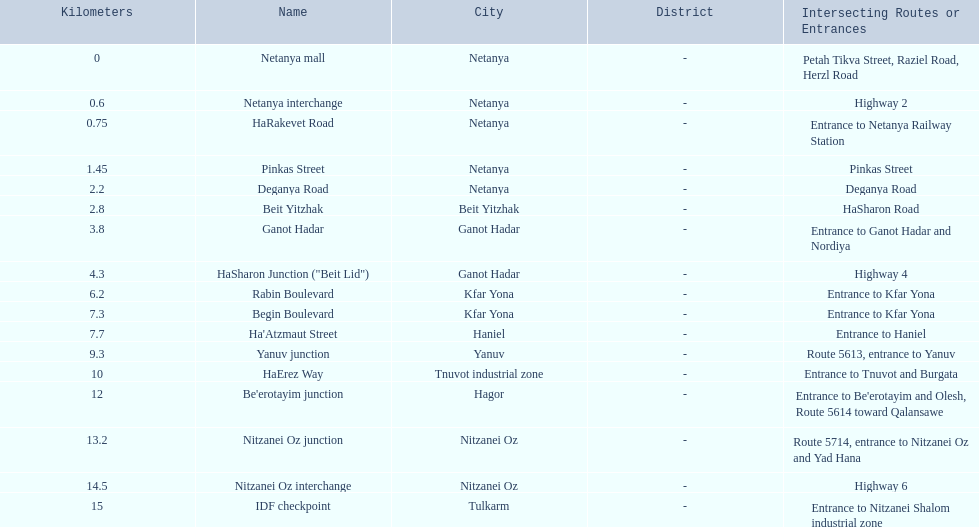What are all of the different portions? Netanya mall, Netanya interchange, HaRakevet Road, Pinkas Street, Deganya Road, Beit Yitzhak, Ganot Hadar, HaSharon Junction ("Beit Lid"), Rabin Boulevard, Begin Boulevard, Ha'Atzmaut Street, Yanuv junction, HaErez Way, Be'erotayim junction, Nitzanei Oz junction, Nitzanei Oz interchange, IDF checkpoint. What is the intersecting route for rabin boulevard? Entrance to Kfar Yona. What portion also has an intersecting route of entrance to kfar yona? Begin Boulevard. 